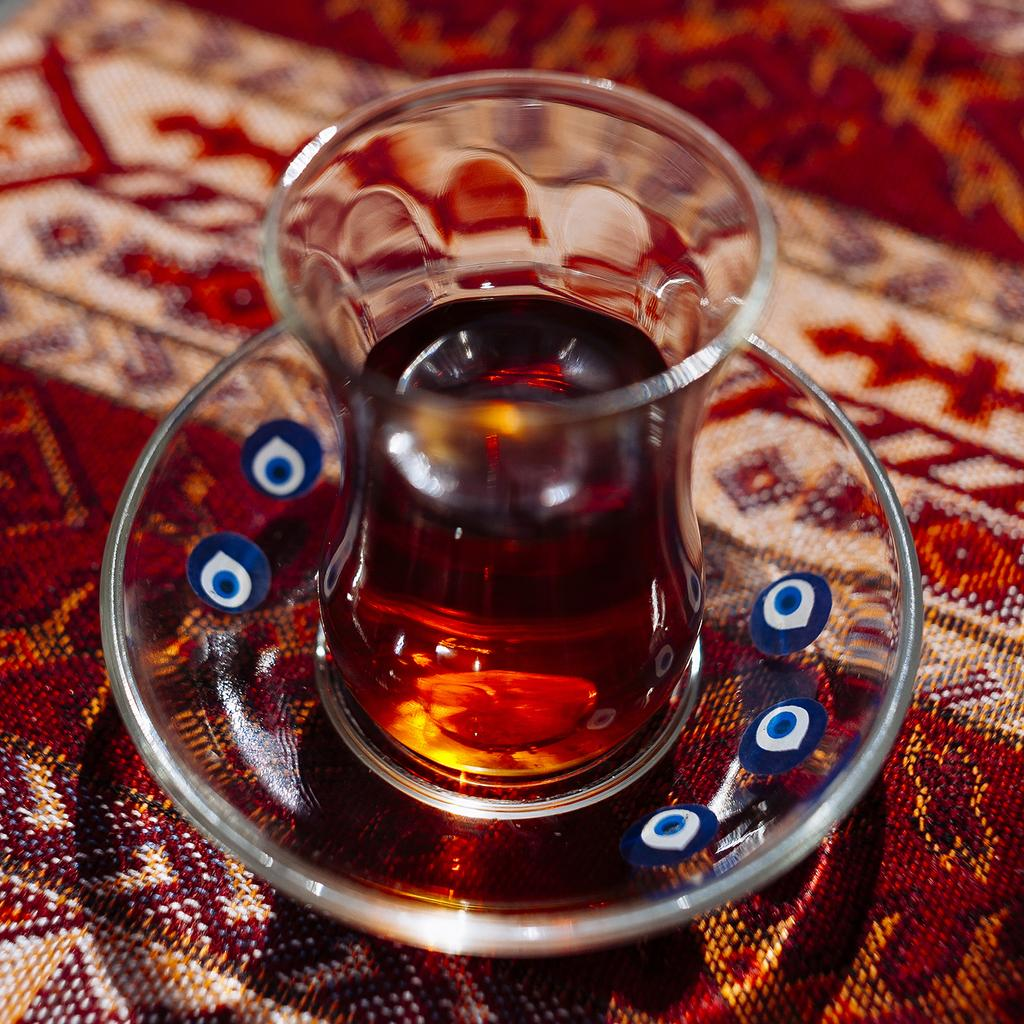What type of container is visible in the image? There is a glass bowl in the image. What else is contained in a glass in the image? There is a glass containing liquid in the image. What color and pattern is the carpet in the image? The carpet at the bottom of the image is white and red in color. How would you describe the quality of the image's background? The image is blurred in the background. What type of brush is being used to clean the floor in the image? There is no brush or floor cleaning activity depicted in the image. What is the mass of the objects on the floor in the image? There are no objects on the floor in the image, so it is impossible to determine their mass. 